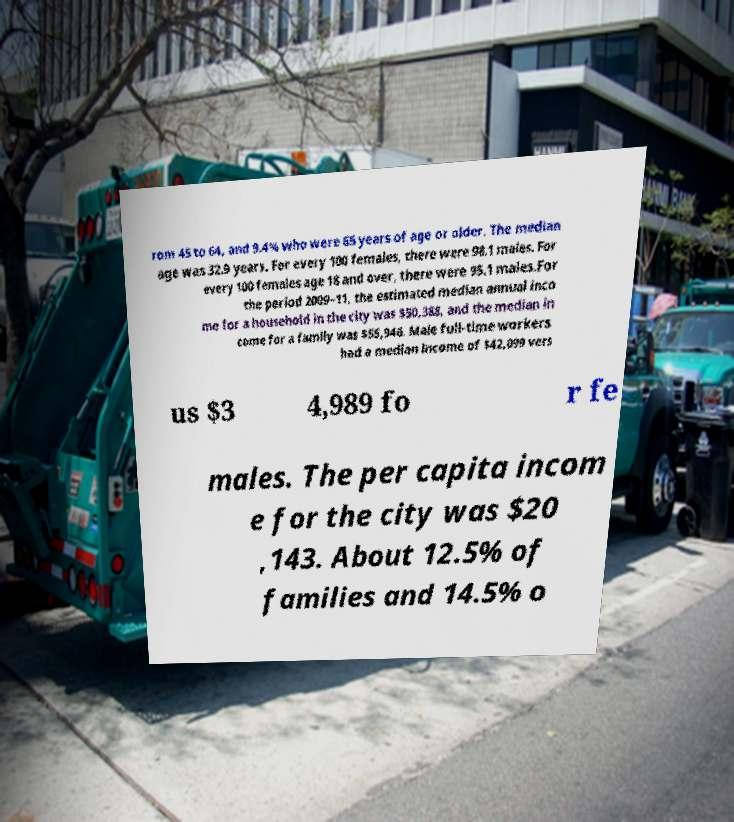Could you extract and type out the text from this image? rom 45 to 64, and 9.4% who were 65 years of age or older. The median age was 32.9 years. For every 100 females, there were 98.1 males. For every 100 females age 18 and over, there were 95.1 males.For the period 2009–11, the estimated median annual inco me for a household in the city was $50,388, and the median in come for a family was $55,946. Male full-time workers had a median income of $42,099 vers us $3 4,989 fo r fe males. The per capita incom e for the city was $20 ,143. About 12.5% of families and 14.5% o 